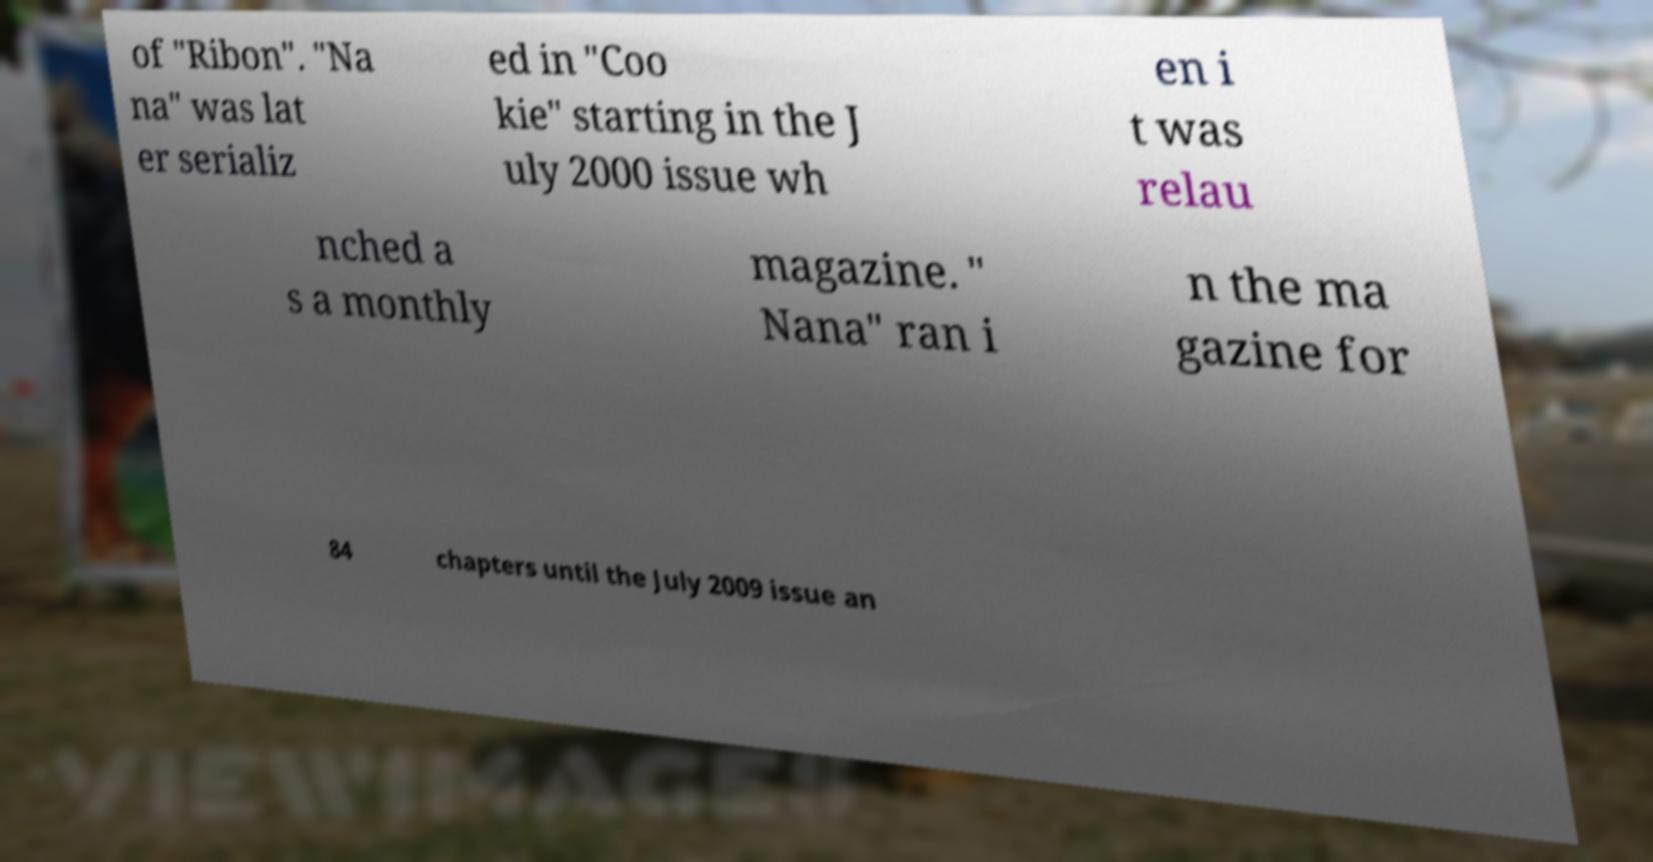Could you assist in decoding the text presented in this image and type it out clearly? of "Ribon". "Na na" was lat er serializ ed in "Coo kie" starting in the J uly 2000 issue wh en i t was relau nched a s a monthly magazine. " Nana" ran i n the ma gazine for 84 chapters until the July 2009 issue an 